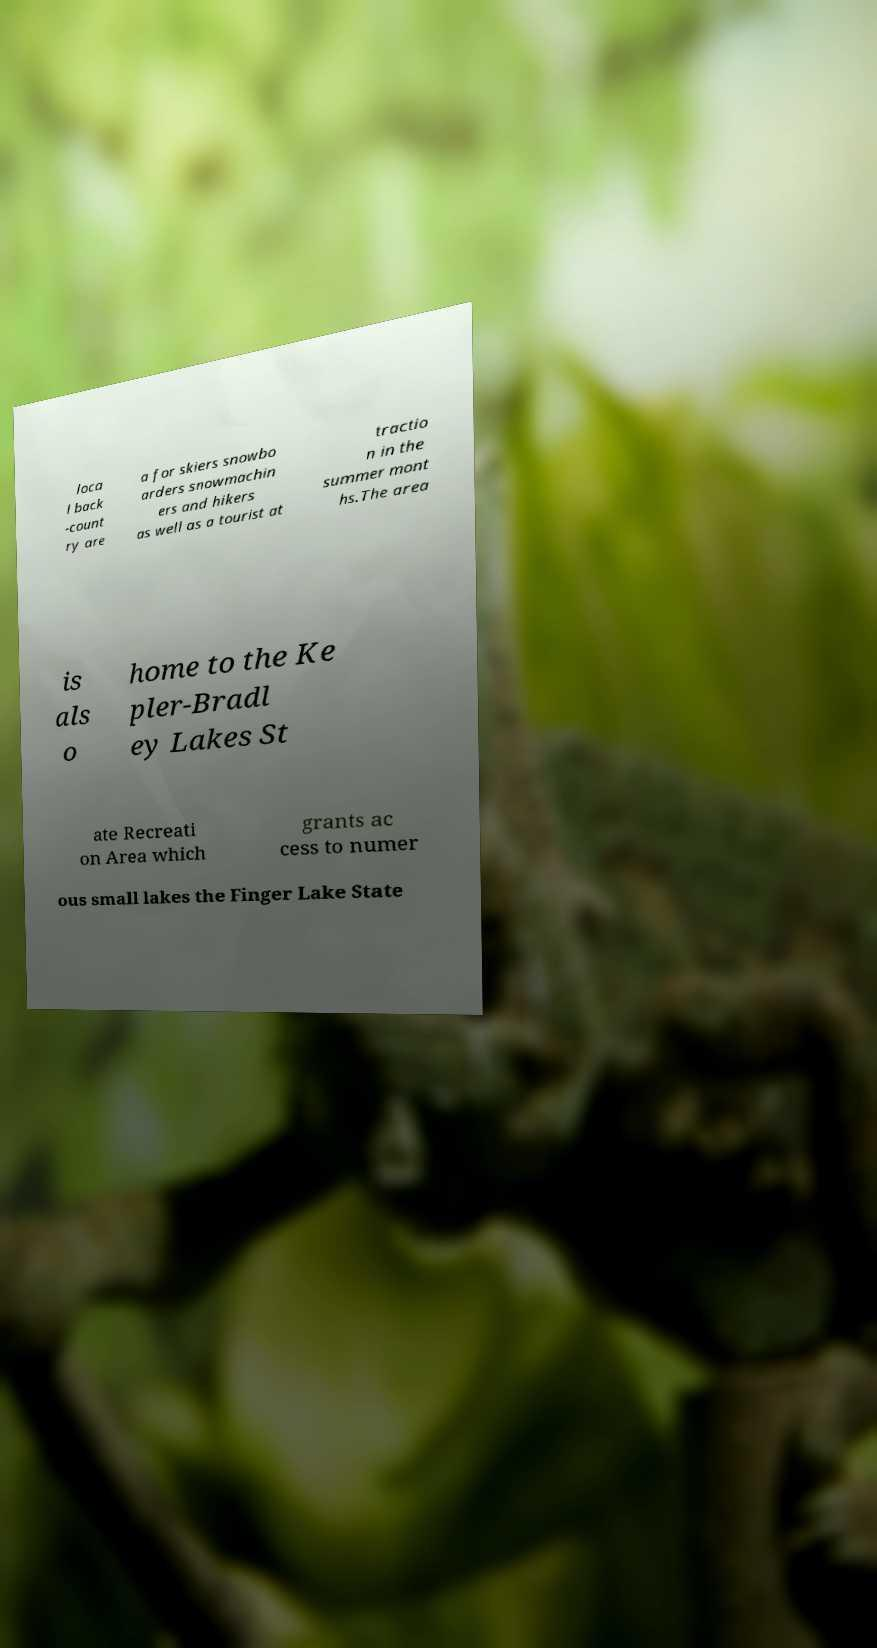For documentation purposes, I need the text within this image transcribed. Could you provide that? loca l back -count ry are a for skiers snowbo arders snowmachin ers and hikers as well as a tourist at tractio n in the summer mont hs.The area is als o home to the Ke pler-Bradl ey Lakes St ate Recreati on Area which grants ac cess to numer ous small lakes the Finger Lake State 